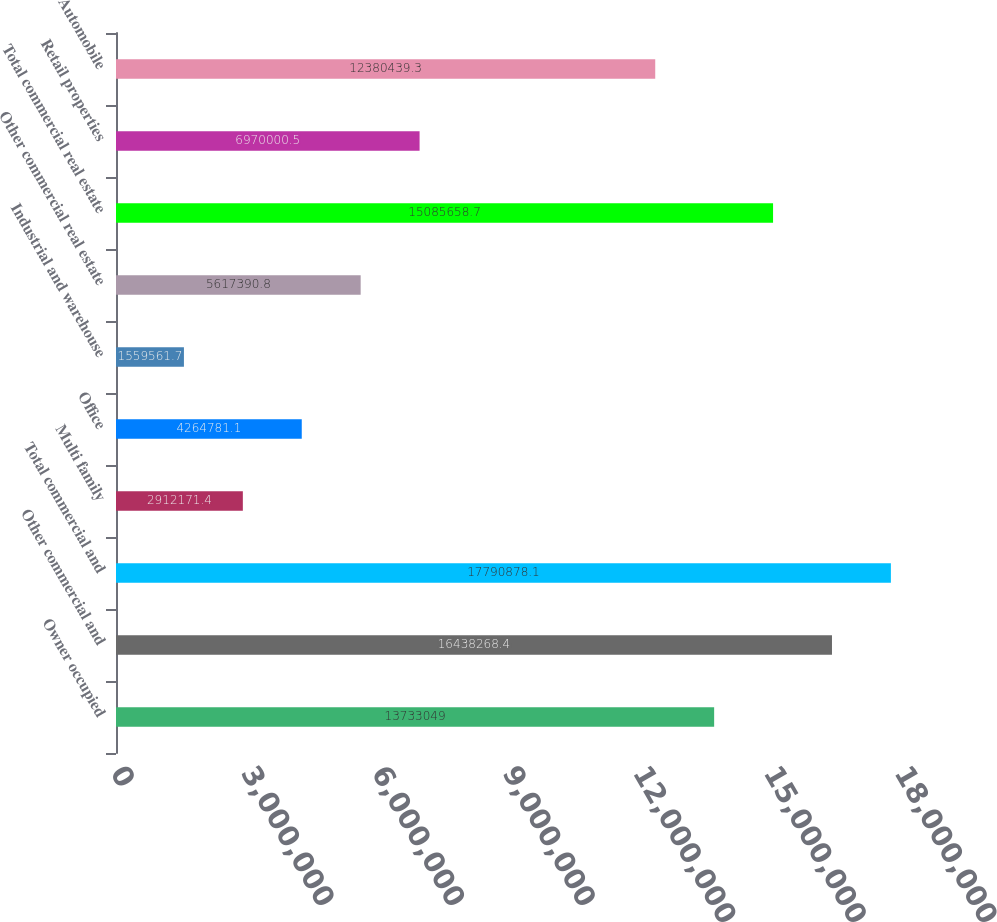<chart> <loc_0><loc_0><loc_500><loc_500><bar_chart><fcel>Owner occupied<fcel>Other commercial and<fcel>Total commercial and<fcel>Multi family<fcel>Office<fcel>Industrial and warehouse<fcel>Other commercial real estate<fcel>Total commercial real estate<fcel>Retail properties<fcel>Automobile<nl><fcel>1.3733e+07<fcel>1.64383e+07<fcel>1.77909e+07<fcel>2.91217e+06<fcel>4.26478e+06<fcel>1.55956e+06<fcel>5.61739e+06<fcel>1.50857e+07<fcel>6.97e+06<fcel>1.23804e+07<nl></chart> 